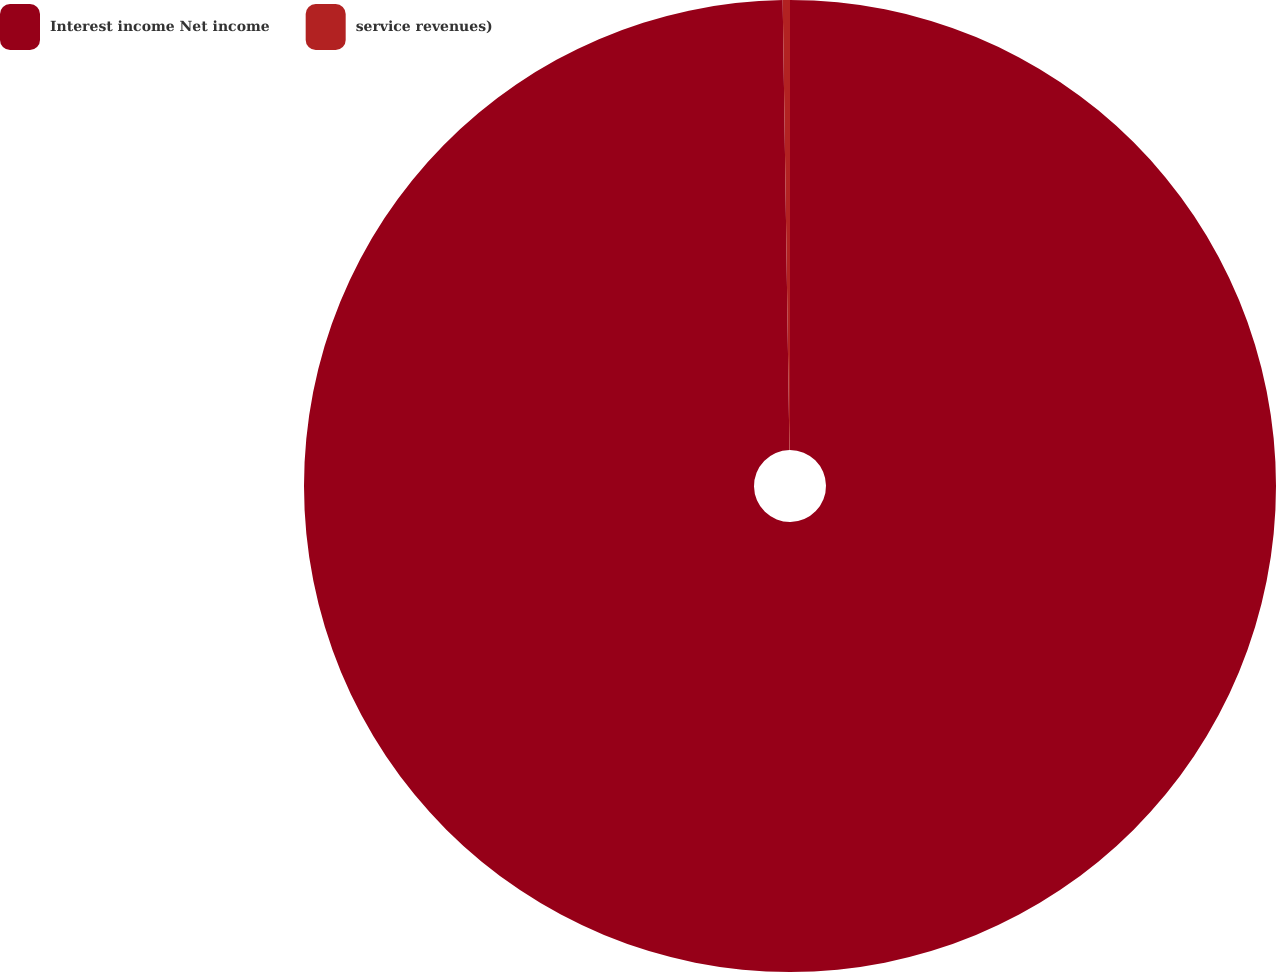Convert chart. <chart><loc_0><loc_0><loc_500><loc_500><pie_chart><fcel>Interest income Net income<fcel>service revenues)<nl><fcel>99.76%<fcel>0.24%<nl></chart> 